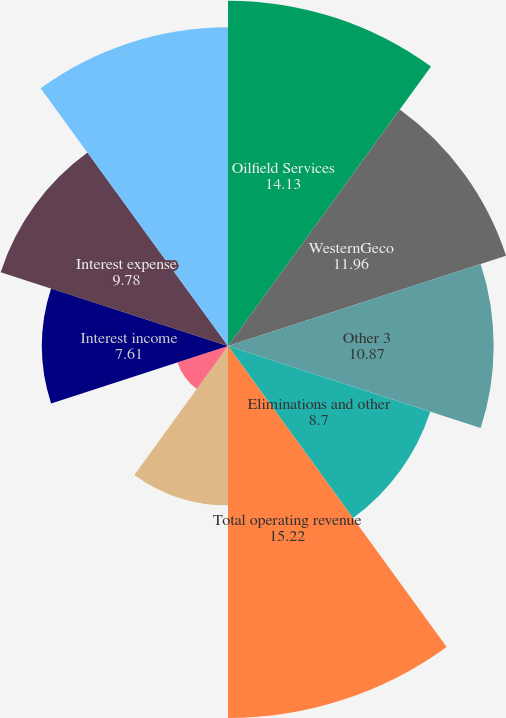<chart> <loc_0><loc_0><loc_500><loc_500><pie_chart><fcel>Oilfield Services<fcel>WesternGeco<fcel>Other 3<fcel>Eliminations and other<fcel>Total operating revenue<fcel>increase (decrease) over prior<fcel>Minority interest<fcel>Interest income<fcel>Interest expense<fcel>Income (loss) continuing<nl><fcel>14.13%<fcel>11.96%<fcel>10.87%<fcel>8.7%<fcel>15.22%<fcel>6.52%<fcel>2.17%<fcel>7.61%<fcel>9.78%<fcel>13.04%<nl></chart> 